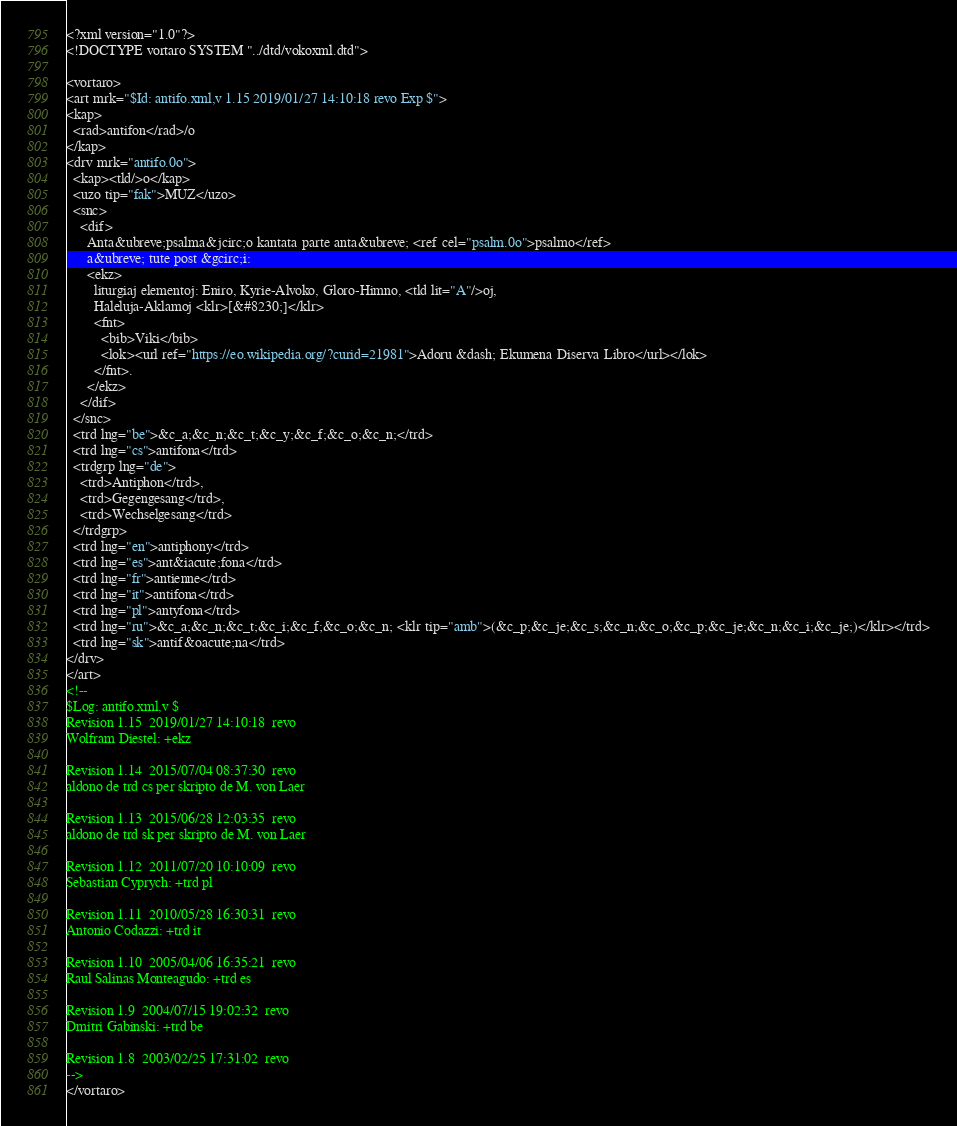<code> <loc_0><loc_0><loc_500><loc_500><_XML_><?xml version="1.0"?>
<!DOCTYPE vortaro SYSTEM "../dtd/vokoxml.dtd">

<vortaro>
<art mrk="$Id: antifo.xml,v 1.15 2019/01/27 14:10:18 revo Exp $">
<kap>
  <rad>antifon</rad>/o
</kap>
<drv mrk="antifo.0o">
  <kap><tld/>o</kap>
  <uzo tip="fak">MUZ</uzo>
  <snc>
    <dif>
      Anta&ubreve;psalma&jcirc;o kantata parte anta&ubreve; <ref cel="psalm.0o">psalmo</ref>
      a&ubreve; tute post &gcirc;i:
      <ekz>
        liturgiaj elementoj: Eniro, Kyrie-Alvoko, Gloro-Himno, <tld lit="A"/>oj,
        Haleluja-Aklamoj <klr>[&#8230;]</klr>
        <fnt>
          <bib>Viki</bib>
          <lok><url ref="https://eo.wikipedia.org/?curid=21981">Adoru &dash; Ekumena Diserva Libro</url></lok>
        </fnt>.
      </ekz>
    </dif>
  </snc>
  <trd lng="be">&c_a;&c_n;&c_t;&c_y;&c_f;&c_o;&c_n;</trd>
  <trd lng="cs">antifona</trd>
  <trdgrp lng="de">
    <trd>Antiphon</trd>,
    <trd>Gegengesang</trd>,
    <trd>Wechselgesang</trd>
  </trdgrp>
  <trd lng="en">antiphony</trd>
  <trd lng="es">ant&iacute;fona</trd>
  <trd lng="fr">antienne</trd>
  <trd lng="it">antifona</trd>
  <trd lng="pl">antyfona</trd>
  <trd lng="ru">&c_a;&c_n;&c_t;&c_i;&c_f;&c_o;&c_n; <klr tip="amb">(&c_p;&c_je;&c_s;&c_n;&c_o;&c_p;&c_je;&c_n;&c_i;&c_je;)</klr></trd>
  <trd lng="sk">antif&oacute;na</trd>
</drv>
</art>
<!--
$Log: antifo.xml,v $
Revision 1.15  2019/01/27 14:10:18  revo
Wolfram Diestel: +ekz

Revision 1.14  2015/07/04 08:37:30  revo
aldono de trd cs per skripto de M. von Laer

Revision 1.13  2015/06/28 12:03:35  revo
aldono de trd sk per skripto de M. von Laer

Revision 1.12  2011/07/20 10:10:09  revo
Sebastian Cyprych: +trd pl

Revision 1.11  2010/05/28 16:30:31  revo
Antonio Codazzi: +trd it

Revision 1.10  2005/04/06 16:35:21  revo
Raul Salinas Monteagudo: +trd es

Revision 1.9  2004/07/15 19:02:32  revo
Dmitri Gabinski: +trd be

Revision 1.8  2003/02/25 17:31:02  revo
-->
</vortaro>
</code> 